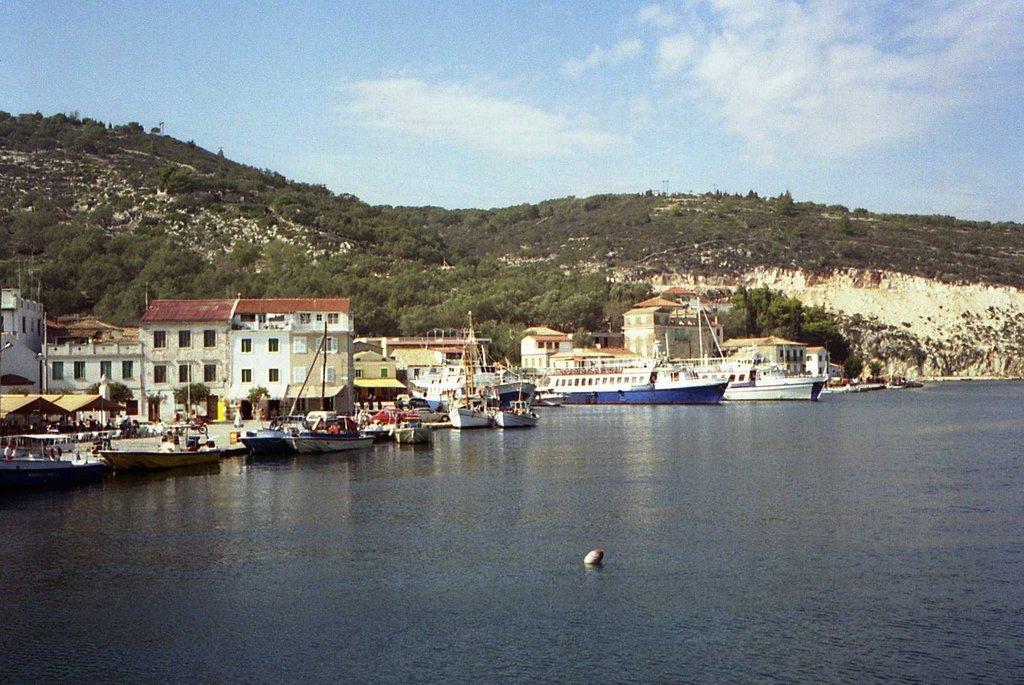Can you describe this image briefly? In this picture I can see the water in front and in the middle of this picture I see number of buildings and number of boats and in the background I see number of trees and the clear sky. 